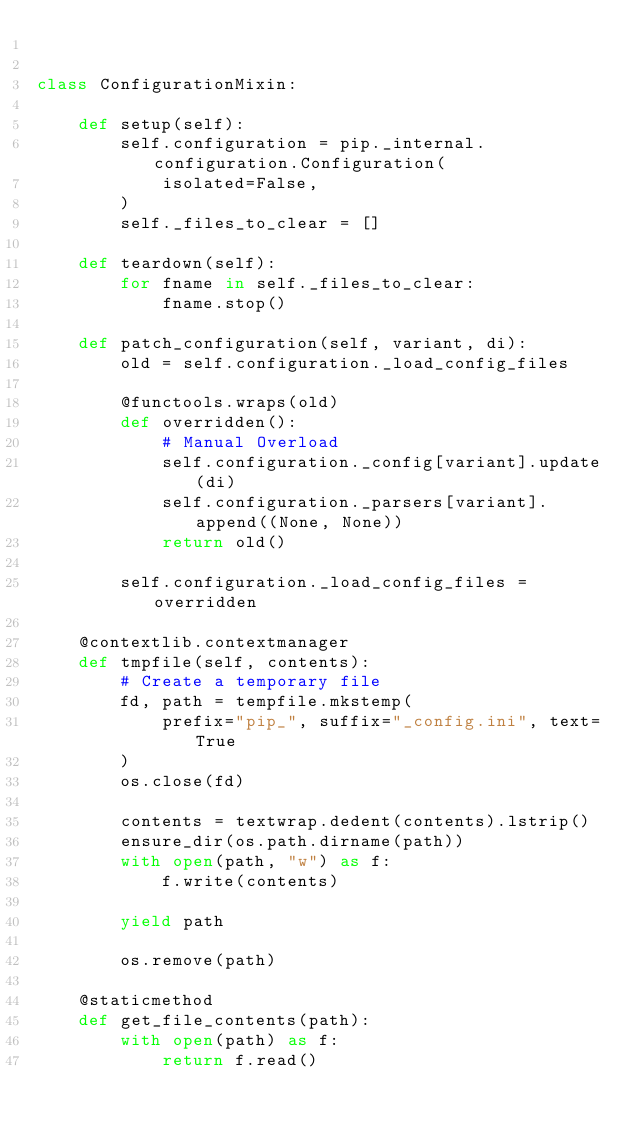Convert code to text. <code><loc_0><loc_0><loc_500><loc_500><_Python_>

class ConfigurationMixin:

    def setup(self):
        self.configuration = pip._internal.configuration.Configuration(
            isolated=False,
        )
        self._files_to_clear = []

    def teardown(self):
        for fname in self._files_to_clear:
            fname.stop()

    def patch_configuration(self, variant, di):
        old = self.configuration._load_config_files

        @functools.wraps(old)
        def overridden():
            # Manual Overload
            self.configuration._config[variant].update(di)
            self.configuration._parsers[variant].append((None, None))
            return old()

        self.configuration._load_config_files = overridden

    @contextlib.contextmanager
    def tmpfile(self, contents):
        # Create a temporary file
        fd, path = tempfile.mkstemp(
            prefix="pip_", suffix="_config.ini", text=True
        )
        os.close(fd)

        contents = textwrap.dedent(contents).lstrip()
        ensure_dir(os.path.dirname(path))
        with open(path, "w") as f:
            f.write(contents)

        yield path

        os.remove(path)

    @staticmethod
    def get_file_contents(path):
        with open(path) as f:
            return f.read()
</code> 